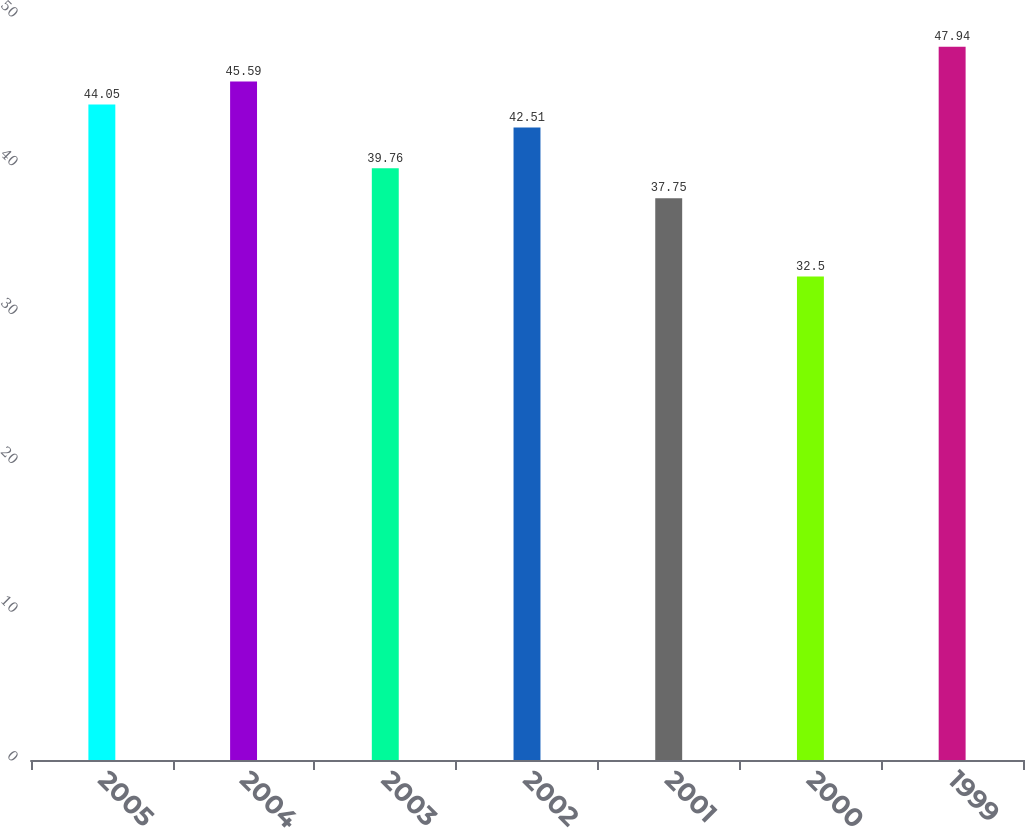Convert chart to OTSL. <chart><loc_0><loc_0><loc_500><loc_500><bar_chart><fcel>2005<fcel>2004<fcel>2003<fcel>2002<fcel>2001<fcel>2000<fcel>1999<nl><fcel>44.05<fcel>45.59<fcel>39.76<fcel>42.51<fcel>37.75<fcel>32.5<fcel>47.94<nl></chart> 